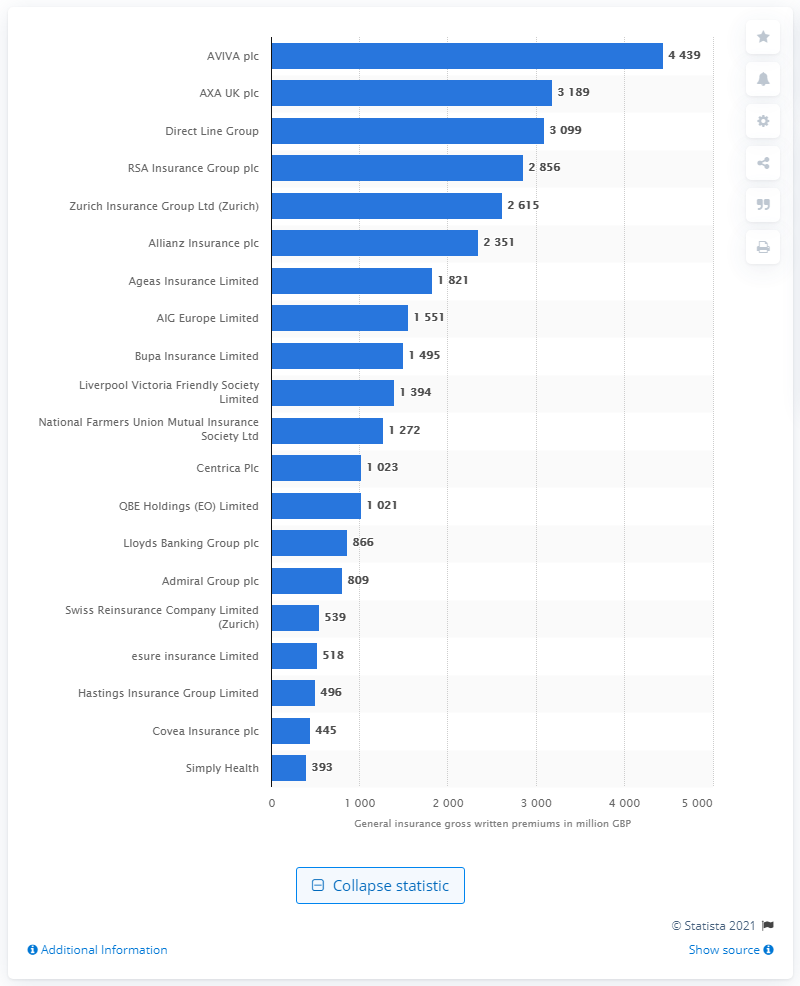Give some essential details in this illustration. AVIVA Plc had gross written premiums of 4,439 million British Pounds as of December 2014. 